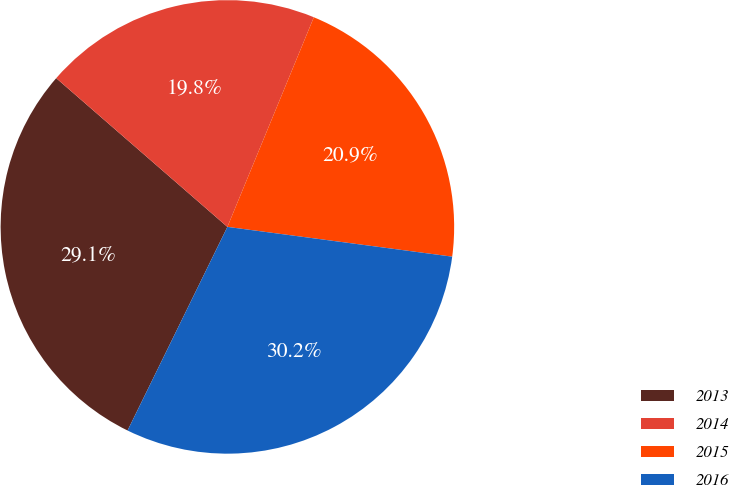Convert chart. <chart><loc_0><loc_0><loc_500><loc_500><pie_chart><fcel>2013<fcel>2014<fcel>2015<fcel>2016<nl><fcel>29.13%<fcel>19.84%<fcel>20.87%<fcel>30.16%<nl></chart> 